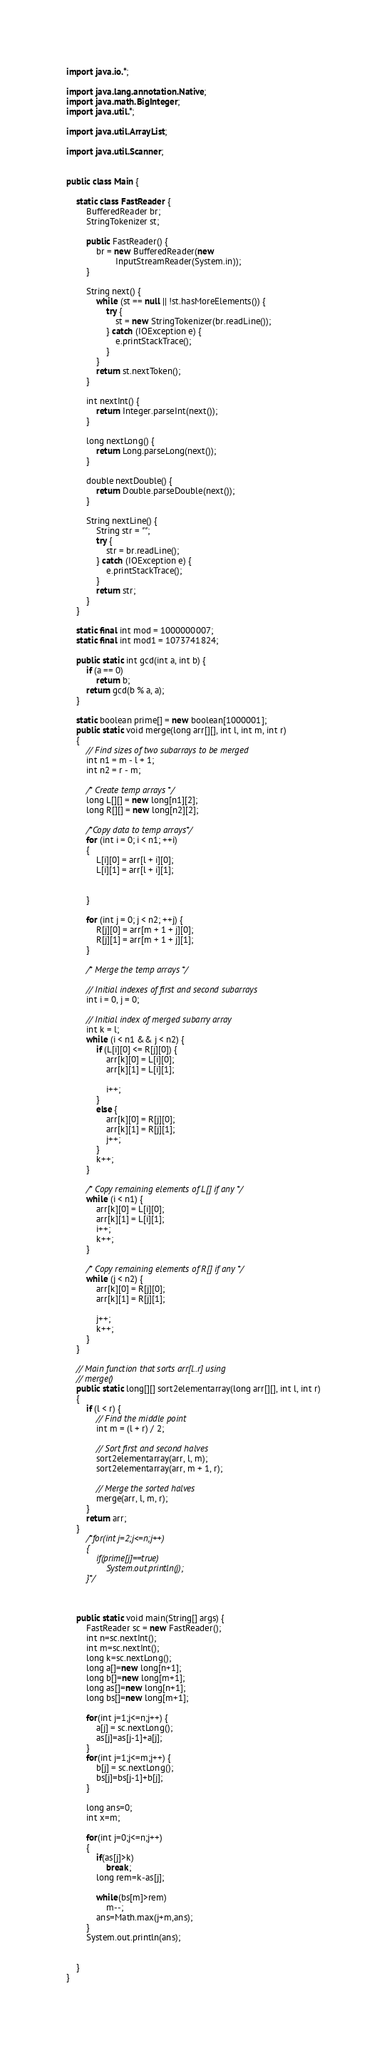<code> <loc_0><loc_0><loc_500><loc_500><_Java_>
import java.io.*;

import java.lang.annotation.Native;
import java.math.BigInteger;
import java.util.*;

import java.util.ArrayList;

import java.util.Scanner;


public class Main {

    static class FastReader {
        BufferedReader br;
        StringTokenizer st;

        public FastReader() {
            br = new BufferedReader(new
                    InputStreamReader(System.in));
        }

        String next() {
            while (st == null || !st.hasMoreElements()) {
                try {
                    st = new StringTokenizer(br.readLine());
                } catch (IOException e) {
                    e.printStackTrace();
                }
            }
            return st.nextToken();
        }

        int nextInt() {
            return Integer.parseInt(next());
        }

        long nextLong() {
            return Long.parseLong(next());
        }

        double nextDouble() {
            return Double.parseDouble(next());
        }

        String nextLine() {
            String str = "";
            try {
                str = br.readLine();
            } catch (IOException e) {
                e.printStackTrace();
            }
            return str;
        }
    }

    static final int mod = 1000000007;
    static final int mod1 = 1073741824;

    public static int gcd(int a, int b) {
        if (a == 0)
            return b;
        return gcd(b % a, a);
    }

    static boolean prime[] = new boolean[1000001];
    public static void merge(long arr[][], int l, int m, int r)
    {
        // Find sizes of two subarrays to be merged
        int n1 = m - l + 1;
        int n2 = r - m;

        /* Create temp arrays */
        long L[][] = new long[n1][2];
        long R[][] = new long[n2][2];

        /*Copy data to temp arrays*/
        for (int i = 0; i < n1; ++i)
        {
            L[i][0] = arr[l + i][0];
            L[i][1] = arr[l + i][1];


        }

        for (int j = 0; j < n2; ++j) {
            R[j][0] = arr[m + 1 + j][0];
            R[j][1] = arr[m + 1 + j][1];
        }

        /* Merge the temp arrays */

        // Initial indexes of first and second subarrays
        int i = 0, j = 0;

        // Initial index of merged subarry array
        int k = l;
        while (i < n1 && j < n2) {
            if (L[i][0] <= R[j][0]) {
                arr[k][0] = L[i][0];
                arr[k][1] = L[i][1];

                i++;
            }
            else {
                arr[k][0] = R[j][0];
                arr[k][1] = R[j][1];
                j++;
            }
            k++;
        }

        /* Copy remaining elements of L[] if any */
        while (i < n1) {
            arr[k][0] = L[i][0];
            arr[k][1] = L[i][1];
            i++;
            k++;
        }

        /* Copy remaining elements of R[] if any */
        while (j < n2) {
            arr[k][0] = R[j][0];
            arr[k][1] = R[j][1];

            j++;
            k++;
        }
    }

    // Main function that sorts arr[l..r] using
    // merge()
    public static long[][] sort2elementarray(long arr[][], int l, int r)
    {
        if (l < r) {
            // Find the middle point
            int m = (l + r) / 2;

            // Sort first and second halves
            sort2elementarray(arr, l, m);
            sort2elementarray(arr, m + 1, r);

            // Merge the sorted halves
            merge(arr, l, m, r);
        }
        return arr;
    }
        /*for(int j=2;j<=n;j++)
        {
            if(prime[j]==true)
                System.out.println(j);
        }*/



    public static void main(String[] args) {
        FastReader sc = new FastReader();
        int n=sc.nextInt();
        int m=sc.nextInt();
        long k=sc.nextLong();
        long a[]=new long[n+1];
        long b[]=new long[m+1];
        long as[]=new long[n+1];
        long bs[]=new long[m+1];

        for(int j=1;j<=n;j++) {
            a[j] = sc.nextLong();
            as[j]=as[j-1]+a[j];
        }
        for(int j=1;j<=m;j++) {
            b[j] = sc.nextLong();
            bs[j]=bs[j-1]+b[j];
        }

        long ans=0;
        int x=m;

        for(int j=0;j<=n;j++)
        {
            if(as[j]>k)
                break;
            long rem=k-as[j];

            while(bs[m]>rem)
                m--;
            ans=Math.max(j+m,ans);
        }
        System.out.println(ans);


    }
}


















</code> 